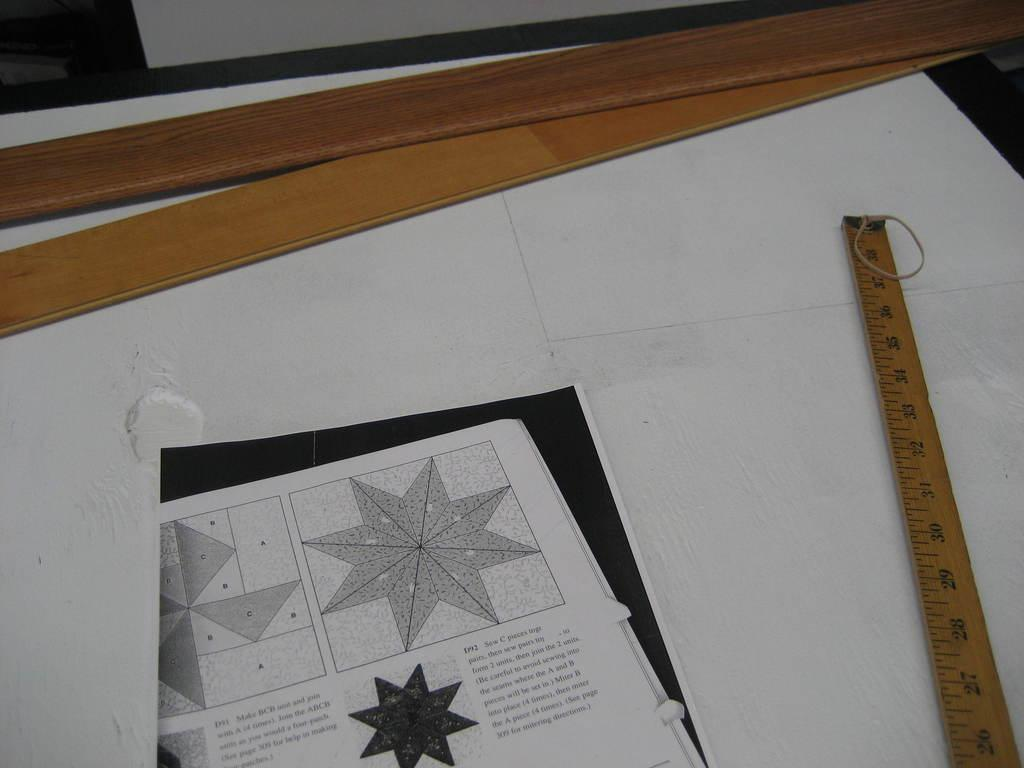<image>
Present a compact description of the photo's key features. A sewing pattern for a traditional quilt design, the pattern is on step 2. 